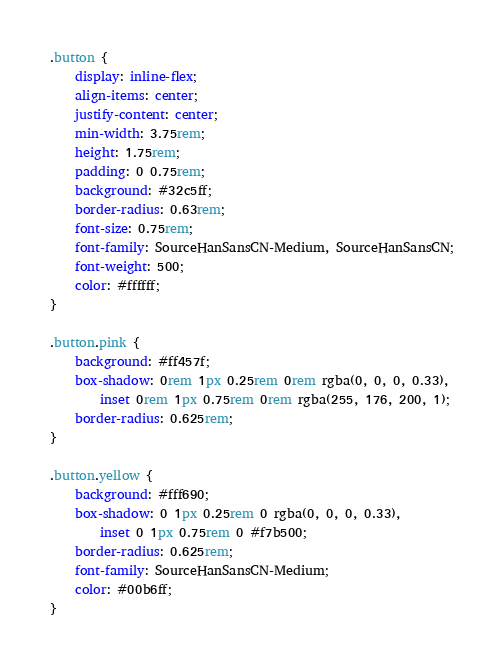Convert code to text. <code><loc_0><loc_0><loc_500><loc_500><_CSS_>.button {
    display: inline-flex;
    align-items: center;
    justify-content: center;
    min-width: 3.75rem;
    height: 1.75rem;
    padding: 0 0.75rem;
    background: #32c5ff;
    border-radius: 0.63rem;
    font-size: 0.75rem;
    font-family: SourceHanSansCN-Medium, SourceHanSansCN;
    font-weight: 500;
    color: #ffffff;
}

.button.pink {
    background: #ff457f;
    box-shadow: 0rem 1px 0.25rem 0rem rgba(0, 0, 0, 0.33),
        inset 0rem 1px 0.75rem 0rem rgba(255, 176, 200, 1);
    border-radius: 0.625rem;
}

.button.yellow {
    background: #fff690;
    box-shadow: 0 1px 0.25rem 0 rgba(0, 0, 0, 0.33),
        inset 0 1px 0.75rem 0 #f7b500;
    border-radius: 0.625rem;
    font-family: SourceHanSansCN-Medium;
    color: #00b6ff;
}
</code> 